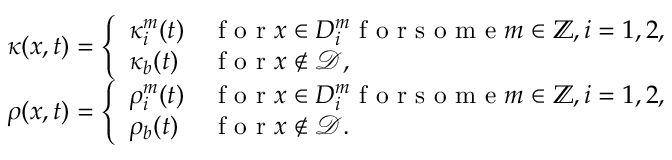<formula> <loc_0><loc_0><loc_500><loc_500>\begin{array} { r } { \kappa ( x , t ) = \left \{ \begin{array} { l l } { \kappa _ { i } ^ { m } ( t ) } & { f o r x \in D _ { i } ^ { m } f o r s o m e m \in \mathbb { Z } , i = 1 , 2 , } \\ { \kappa _ { b } ( t ) } & { f o r x \not \in \mathcal { D } , } \end{array} } \\ { \rho ( x , t ) = \left \{ \begin{array} { l l } { \rho _ { i } ^ { m } ( t ) } & { f o r x \in D _ { i } ^ { m } f o r s o m e m \in \mathbb { Z } , i = 1 , 2 , } \\ { \rho _ { b } ( t ) } & { f o r x \not \in \mathcal { D } . } \end{array} } \end{array}</formula> 